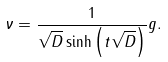<formula> <loc_0><loc_0><loc_500><loc_500>\nu = \frac { 1 } { \sqrt { D } \sinh \left ( t \sqrt { D } \right ) } g .</formula> 